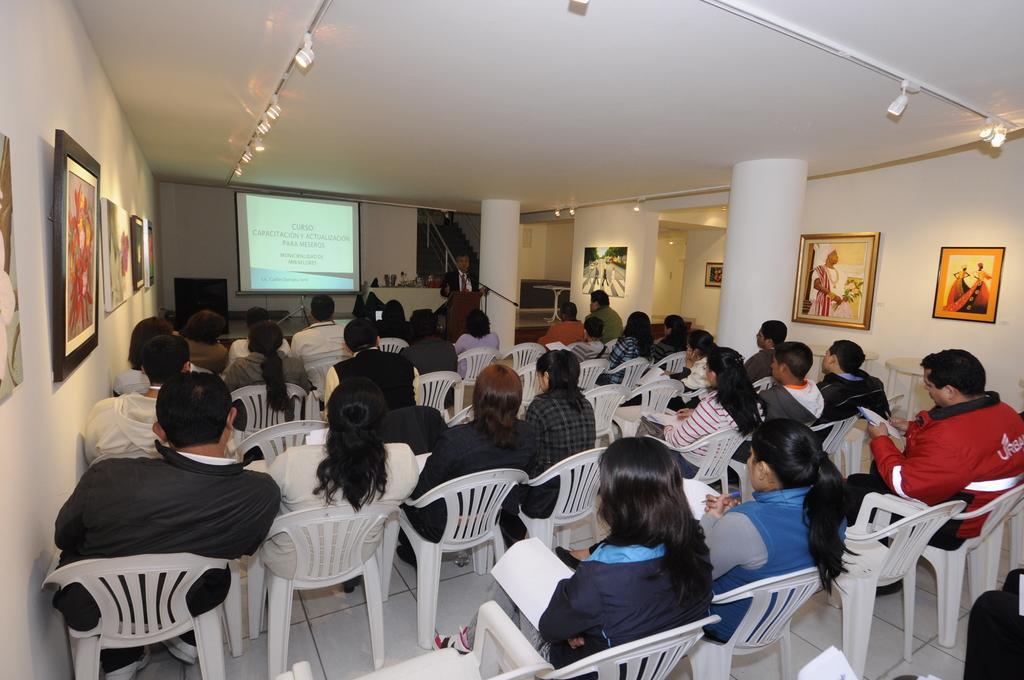How would you summarize this image in a sentence or two? This picture describes about group of people, few are seated on the chairs and a man is standing, in front of them we can see a projector screen, and we can find few paintings on the wall, and also we can see few lights. 